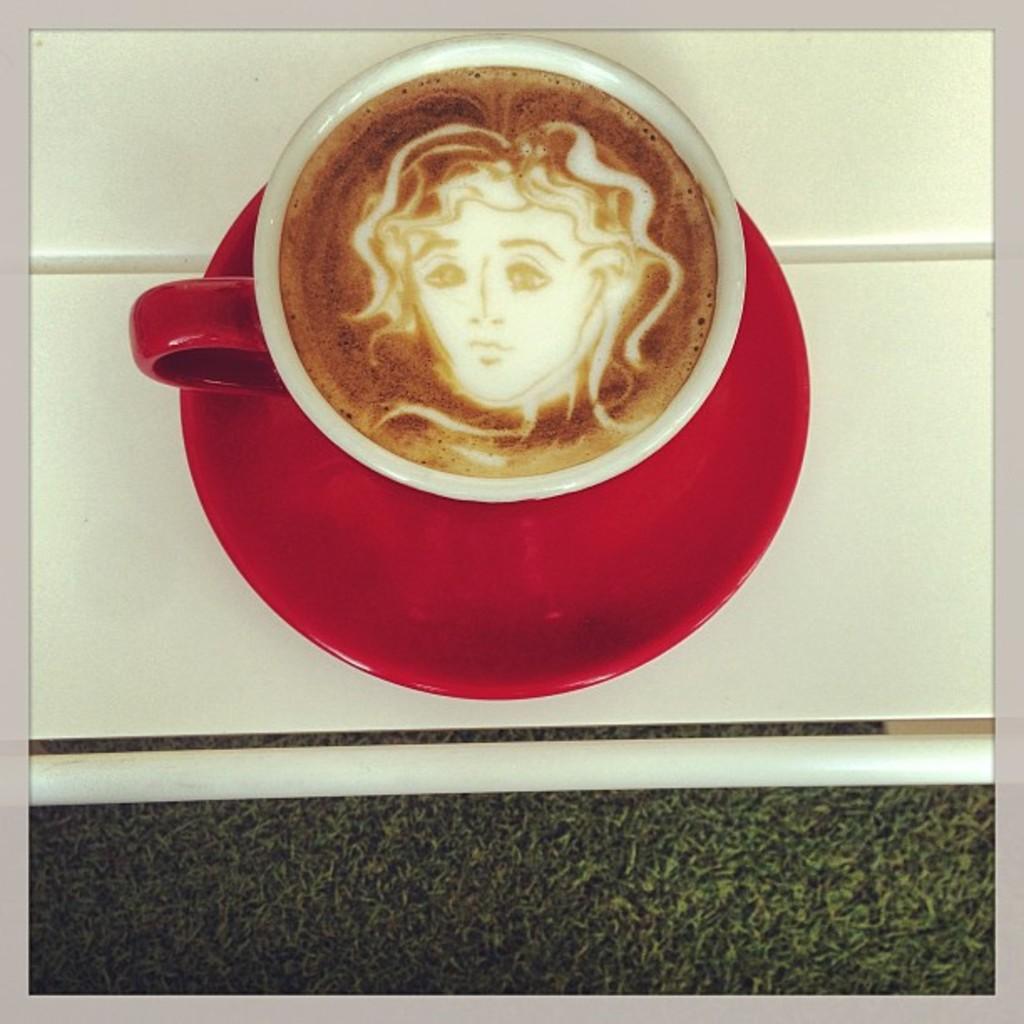Can you describe this image briefly? In this image I see a cup in which there is liquid which is of white and brown in color and it is on a saucer which is of red in color and I see that these both are on a white surface and I see the black surface over here. 